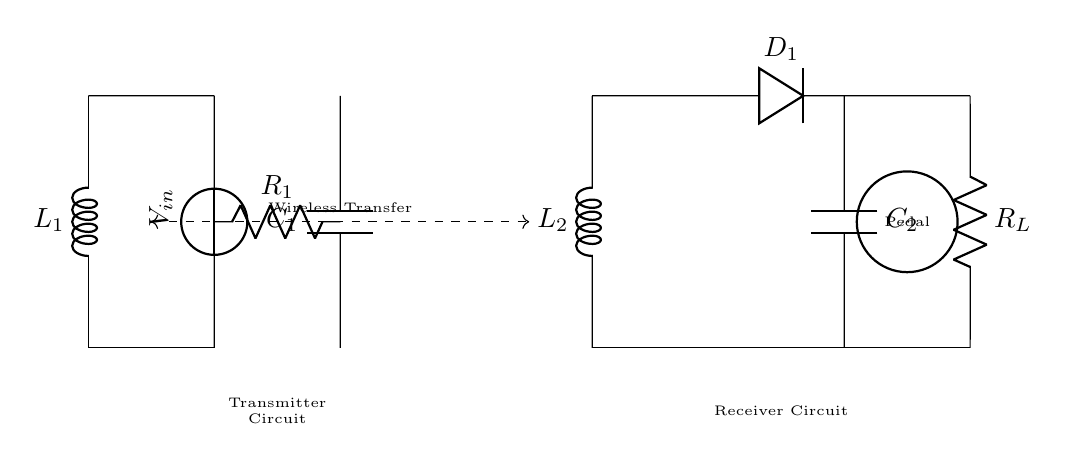What is the input voltage of the transmitter circuit? The input voltage is labeled as V in the circuit diagram, providing the potential difference required to power the transmitter.
Answer: V in What type of component is L1? L1 is labeled as an inductor, which is shown in the circuit diagram as a coil, indicating that it stores energy in a magnetic field.
Answer: Inductor What does R_L represent in the circuit? R_L is the load resistor, typically representing the resistance of the guitar pedal that the circuit is supplying power to.
Answer: Load resistor How many capacitors are in the circuit? The circuit includes two capacitors: C1 in the transmitter circuit and C2 in the receiver circuit, as evidenced by the symbols in the diagram.
Answer: Two What is the function of D1 in the receiver circuit? D1 is a diode, which allows current to flow in one direction, important for converting the AC voltage from the receiver coil into DC voltage for the pedal.
Answer: Diode What is the purpose of wireless transfer indicated in the diagram? The dashed line labeled wireless transfer signifies that energy is being transmitted from the transmitter coil (L1) to the receiver coil (L2) without physical connections.
Answer: Energy transfer Which component connects the transmitter and receiver circuit? The connection is made through the inductors L1 and L2, which enable the transfer of energy wirelessly between the two circuits.
Answer: Inductors 